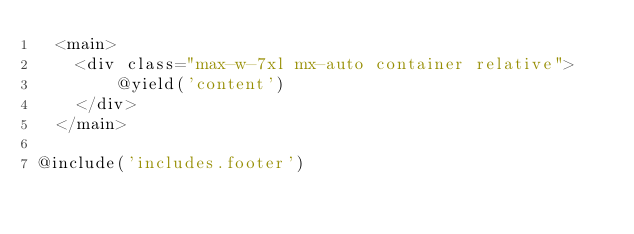<code> <loc_0><loc_0><loc_500><loc_500><_PHP_>  <main>
    <div class="max-w-7xl mx-auto container relative">
        @yield('content')
    </div>
  </main>

@include('includes.footer')
</code> 